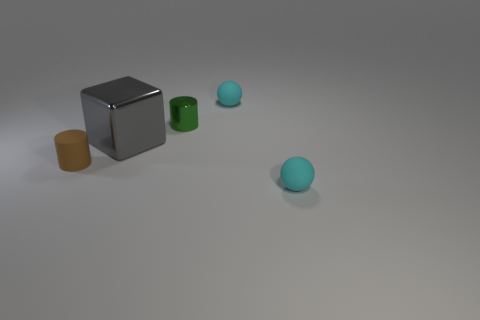Subtract all cyan balls. How many were subtracted if there are1cyan balls left? 1 Add 2 green shiny cylinders. How many objects exist? 7 Subtract all blocks. How many objects are left? 4 Subtract 0 blue blocks. How many objects are left? 5 Subtract all big purple rubber cylinders. Subtract all large cubes. How many objects are left? 4 Add 3 tiny objects. How many tiny objects are left? 7 Add 4 large yellow shiny blocks. How many large yellow shiny blocks exist? 4 